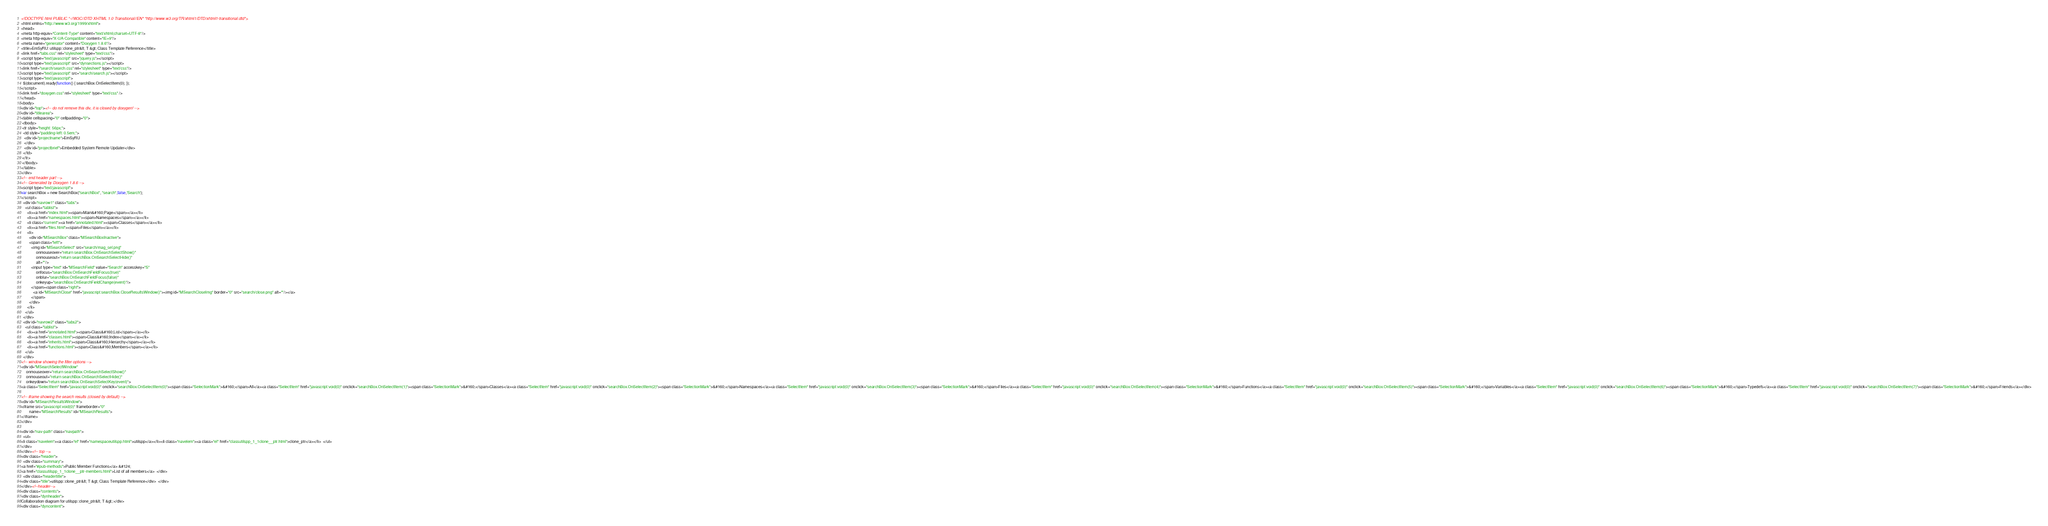<code> <loc_0><loc_0><loc_500><loc_500><_HTML_><!DOCTYPE html PUBLIC "-//W3C//DTD XHTML 1.0 Transitional//EN" "http://www.w3.org/TR/xhtml1/DTD/xhtml1-transitional.dtd">
<html xmlns="http://www.w3.org/1999/xhtml">
<head>
<meta http-equiv="Content-Type" content="text/xhtml;charset=UTF-8"/>
<meta http-equiv="X-UA-Compatible" content="IE=9"/>
<meta name="generator" content="Doxygen 1.8.6"/>
<title>EmSyRU: utilspp::clone_ptr&lt; T &gt; Class Template Reference</title>
<link href="tabs.css" rel="stylesheet" type="text/css"/>
<script type="text/javascript" src="jquery.js"></script>
<script type="text/javascript" src="dynsections.js"></script>
<link href="search/search.css" rel="stylesheet" type="text/css"/>
<script type="text/javascript" src="search/search.js"></script>
<script type="text/javascript">
  $(document).ready(function() { searchBox.OnSelectItem(0); });
</script>
<link href="doxygen.css" rel="stylesheet" type="text/css" />
</head>
<body>
<div id="top"><!-- do not remove this div, it is closed by doxygen! -->
<div id="titlearea">
<table cellspacing="0" cellpadding="0">
 <tbody>
 <tr style="height: 56px;">
  <td style="padding-left: 0.5em;">
   <div id="projectname">EmSyRU
   </div>
   <div id="projectbrief">Embedded System Remote Updater</div>
  </td>
 </tr>
 </tbody>
</table>
</div>
<!-- end header part -->
<!-- Generated by Doxygen 1.8.6 -->
<script type="text/javascript">
var searchBox = new SearchBox("searchBox", "search",false,'Search');
</script>
  <div id="navrow1" class="tabs">
    <ul class="tablist">
      <li><a href="index.html"><span>Main&#160;Page</span></a></li>
      <li><a href="namespaces.html"><span>Namespaces</span></a></li>
      <li class="current"><a href="annotated.html"><span>Classes</span></a></li>
      <li><a href="files.html"><span>Files</span></a></li>
      <li>
        <div id="MSearchBox" class="MSearchBoxInactive">
        <span class="left">
          <img id="MSearchSelect" src="search/mag_sel.png"
               onmouseover="return searchBox.OnSearchSelectShow()"
               onmouseout="return searchBox.OnSearchSelectHide()"
               alt=""/>
          <input type="text" id="MSearchField" value="Search" accesskey="S"
               onfocus="searchBox.OnSearchFieldFocus(true)" 
               onblur="searchBox.OnSearchFieldFocus(false)" 
               onkeyup="searchBox.OnSearchFieldChange(event)"/>
          </span><span class="right">
            <a id="MSearchClose" href="javascript:searchBox.CloseResultsWindow()"><img id="MSearchCloseImg" border="0" src="search/close.png" alt=""/></a>
          </span>
        </div>
      </li>
    </ul>
  </div>
  <div id="navrow2" class="tabs2">
    <ul class="tablist">
      <li><a href="annotated.html"><span>Class&#160;List</span></a></li>
      <li><a href="classes.html"><span>Class&#160;Index</span></a></li>
      <li><a href="inherits.html"><span>Class&#160;Hierarchy</span></a></li>
      <li><a href="functions.html"><span>Class&#160;Members</span></a></li>
    </ul>
  </div>
<!-- window showing the filter options -->
<div id="MSearchSelectWindow"
     onmouseover="return searchBox.OnSearchSelectShow()"
     onmouseout="return searchBox.OnSearchSelectHide()"
     onkeydown="return searchBox.OnSearchSelectKey(event)">
<a class="SelectItem" href="javascript:void(0)" onclick="searchBox.OnSelectItem(0)"><span class="SelectionMark">&#160;</span>All</a><a class="SelectItem" href="javascript:void(0)" onclick="searchBox.OnSelectItem(1)"><span class="SelectionMark">&#160;</span>Classes</a><a class="SelectItem" href="javascript:void(0)" onclick="searchBox.OnSelectItem(2)"><span class="SelectionMark">&#160;</span>Namespaces</a><a class="SelectItem" href="javascript:void(0)" onclick="searchBox.OnSelectItem(3)"><span class="SelectionMark">&#160;</span>Files</a><a class="SelectItem" href="javascript:void(0)" onclick="searchBox.OnSelectItem(4)"><span class="SelectionMark">&#160;</span>Functions</a><a class="SelectItem" href="javascript:void(0)" onclick="searchBox.OnSelectItem(5)"><span class="SelectionMark">&#160;</span>Variables</a><a class="SelectItem" href="javascript:void(0)" onclick="searchBox.OnSelectItem(6)"><span class="SelectionMark">&#160;</span>Typedefs</a><a class="SelectItem" href="javascript:void(0)" onclick="searchBox.OnSelectItem(7)"><span class="SelectionMark">&#160;</span>Friends</a></div>

<!-- iframe showing the search results (closed by default) -->
<div id="MSearchResultsWindow">
<iframe src="javascript:void(0)" frameborder="0" 
        name="MSearchResults" id="MSearchResults">
</iframe>
</div>

<div id="nav-path" class="navpath">
  <ul>
<li class="navelem"><a class="el" href="namespaceutilspp.html">utilspp</a></li><li class="navelem"><a class="el" href="classutilspp_1_1clone__ptr.html">clone_ptr</a></li>  </ul>
</div>
</div><!-- top -->
<div class="header">
  <div class="summary">
<a href="#pub-methods">Public Member Functions</a> &#124;
<a href="classutilspp_1_1clone__ptr-members.html">List of all members</a>  </div>
  <div class="headertitle">
<div class="title">utilspp::clone_ptr&lt; T &gt; Class Template Reference</div>  </div>
</div><!--header-->
<div class="contents">
<div class="dynheader">
Collaboration diagram for utilspp::clone_ptr&lt; T &gt;:</div>
<div class="dyncontent"></code> 